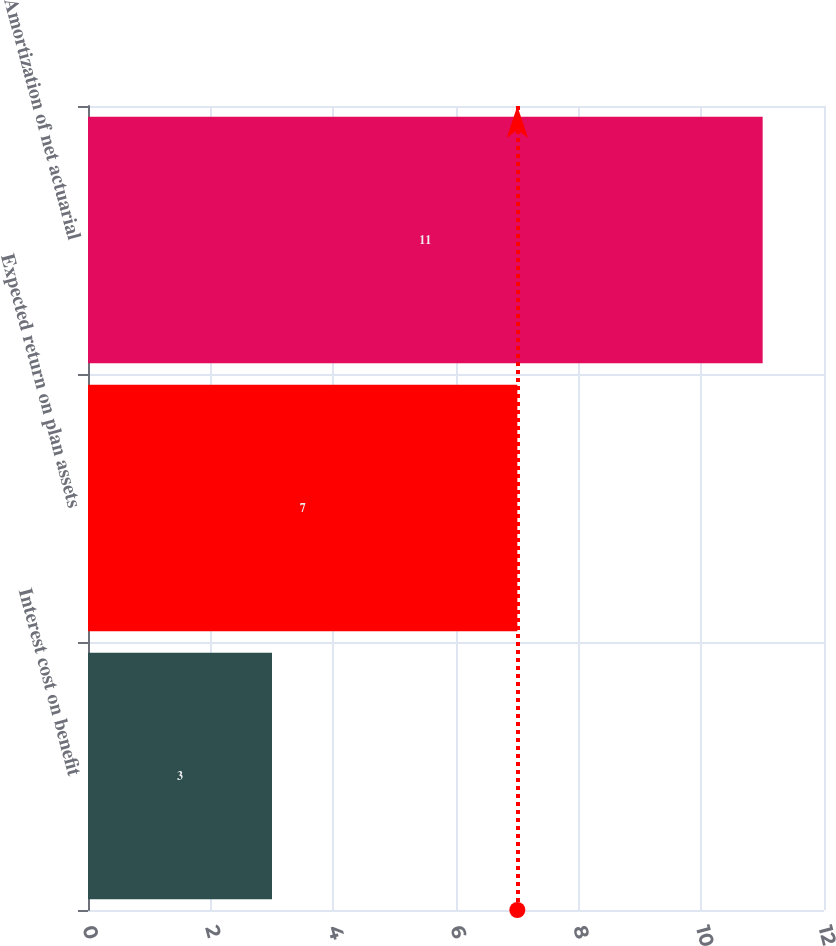Convert chart. <chart><loc_0><loc_0><loc_500><loc_500><bar_chart><fcel>Interest cost on benefit<fcel>Expected return on plan assets<fcel>Amortization of net actuarial<nl><fcel>3<fcel>7<fcel>11<nl></chart> 